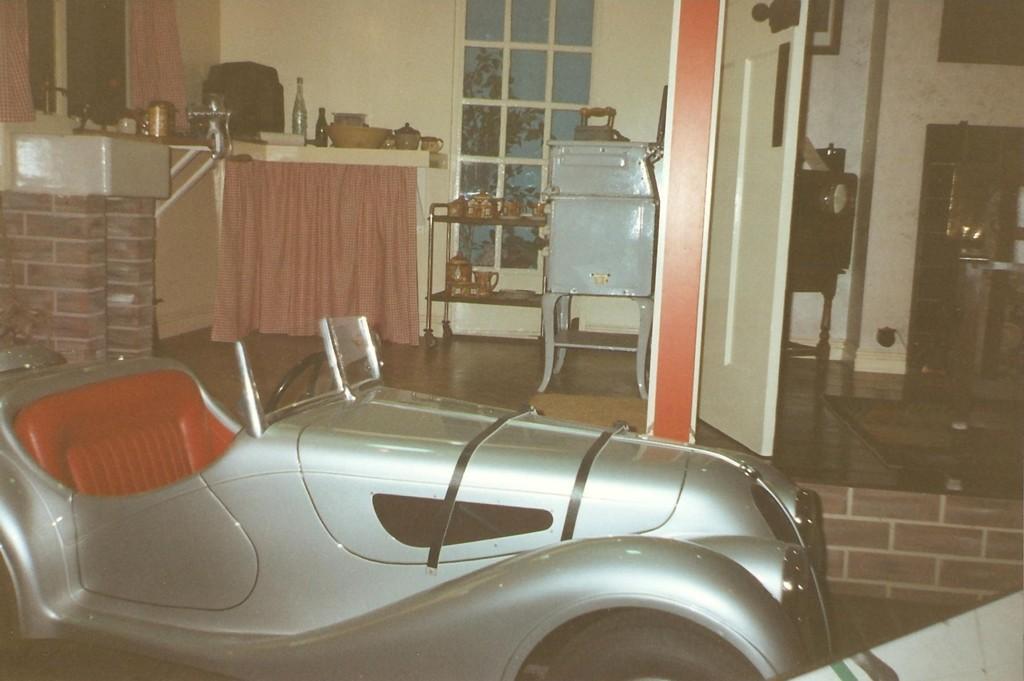Please provide a concise description of this image. In this image we can see a grey color vehicle. Behind the vehicle, we can see a door, window, wall, curtain, sink, cups, doormat, bottles and so many things. It seems like table on the right side of the image and there is a carpet on the floor. One frame is attached to the wall. We can see one iron on a grey color table in the middle of the image. 